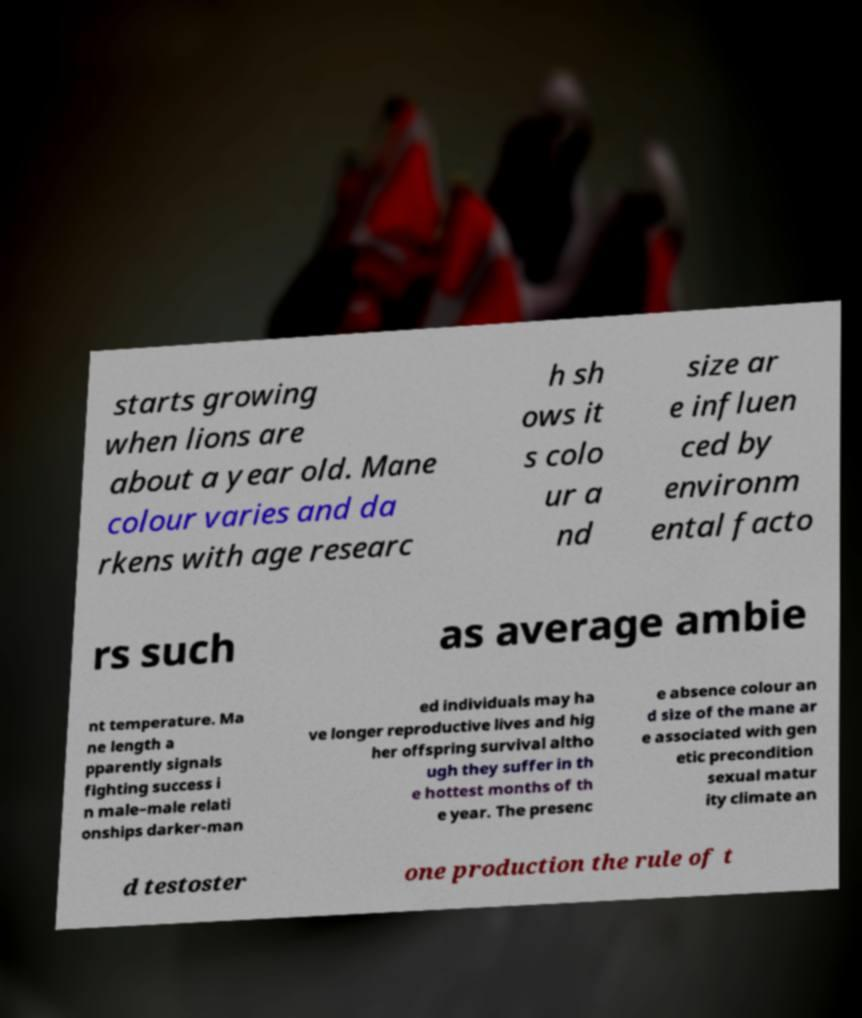Please identify and transcribe the text found in this image. starts growing when lions are about a year old. Mane colour varies and da rkens with age researc h sh ows it s colo ur a nd size ar e influen ced by environm ental facto rs such as average ambie nt temperature. Ma ne length a pparently signals fighting success i n male–male relati onships darker-man ed individuals may ha ve longer reproductive lives and hig her offspring survival altho ugh they suffer in th e hottest months of th e year. The presenc e absence colour an d size of the mane ar e associated with gen etic precondition sexual matur ity climate an d testoster one production the rule of t 